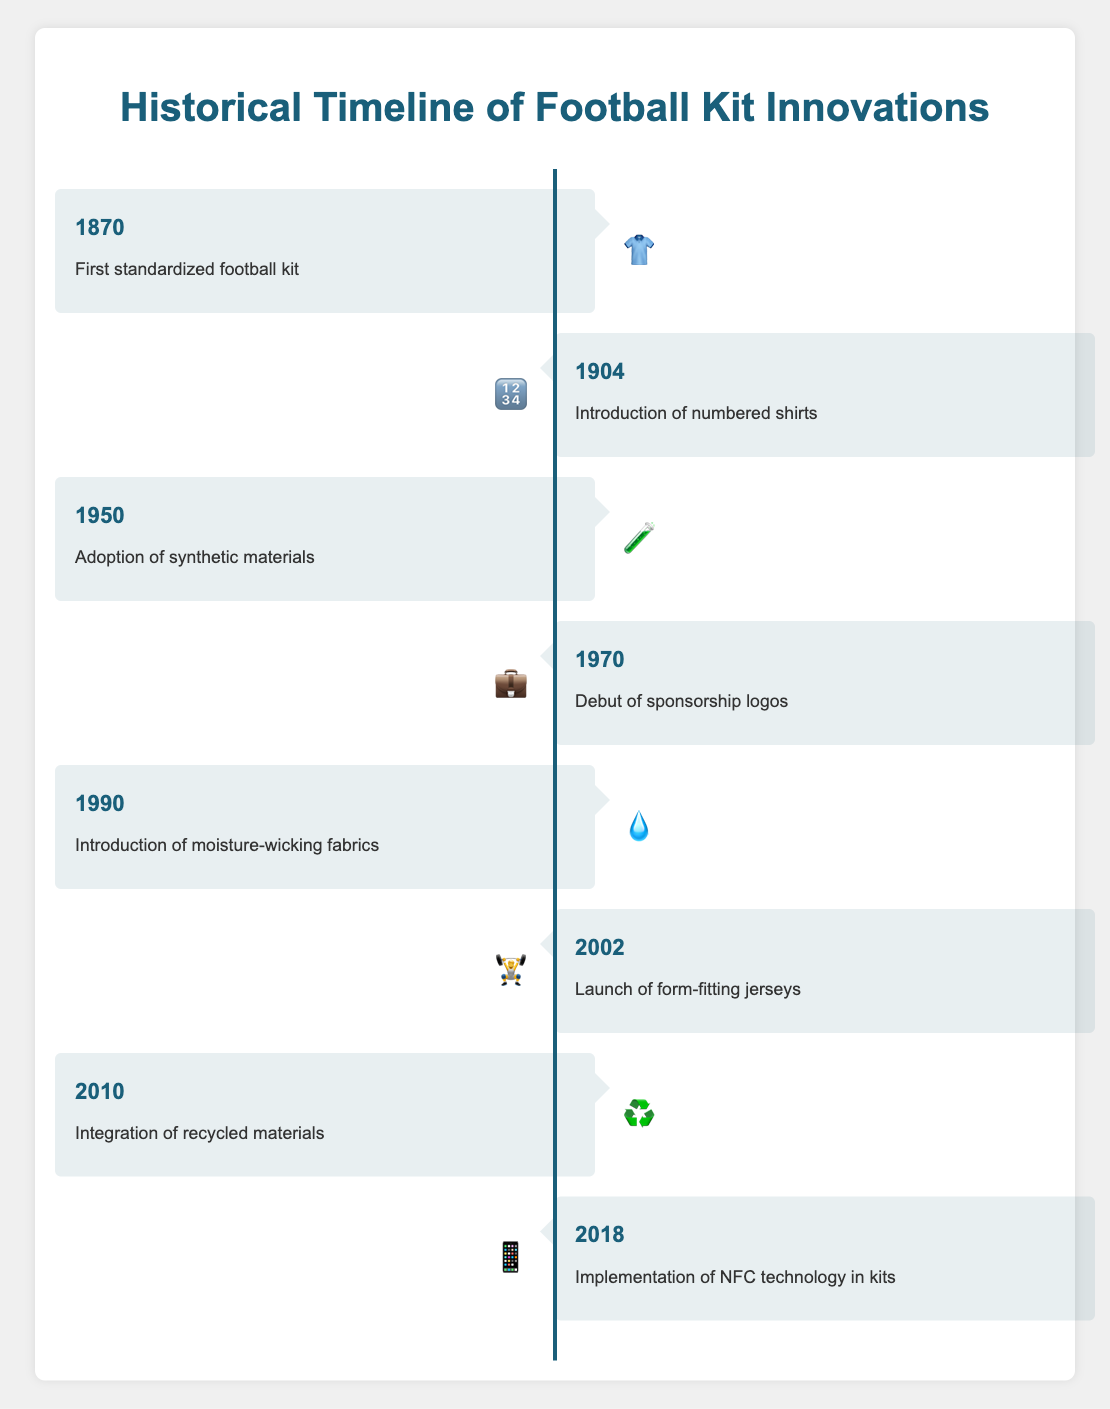What is the title of the figure? The title of the figure is displayed at the very top and represents the central theme of the visual.
Answer: Historical Timeline of Football Kit Innovations Which emoji represents the innovation in 1990? Locate the entry for the year 1990 and check the emoji associated with it.
Answer: 💧 How many innovations are listed in total? Count the number of entries present in the timeline section.
Answer: 8 Which innovation is marked with the 📱 emoji? Find the entry associated with the 📱 emoji and read the innovation text next to it.
Answer: Implementation of NFC technology in kits What innovation occurred around 32 years after the adoption of synthetic materials? The adoption of synthetic materials happened in 1950. Adding 32 years to 1950 gives 1982, so look for the closest year after 1982, which is 1990.
Answer: Introduction of moisture-wicking fabrics Which innovation happened first, the introduction of moisture-wicking fabrics or the debut of sponsorship logos? Compare the years for the "introduction of moisture-wicking fabrics" (1990) and "debut of sponsorship logos" (1970).
Answer: Debut of sponsorship logos What is the time gap between the introduction of form-fitting jerseys and the implementation of NFC technology in kits? Form-fitting jerseys were introduced in 2002, and NFC technology was implemented in 2018. Subtract 2002 from 2018 to get the time gap.
Answer: 16 years How many innovations were introduced in the 20th century? Identify the entries from the 20th century (1901-2000). They are in the years 1904, 1950, 1970, and 1990.
Answer: 4 Which innovation came after the debut of sponsorship logos and before the launch of form-fitting jerseys? Look for the innovation between 1970 (Debut of sponsorship logos) and 2002 (Launch of form-fitting jerseys).
Answer: Introduction of moisture-wicking fabrics What is the common theme shared by all the innovations in the timeline? Based on the title and innovations listed, summarize the overarching theme connecting all entries.
Answer: Significant advancements in football kit design and technology 